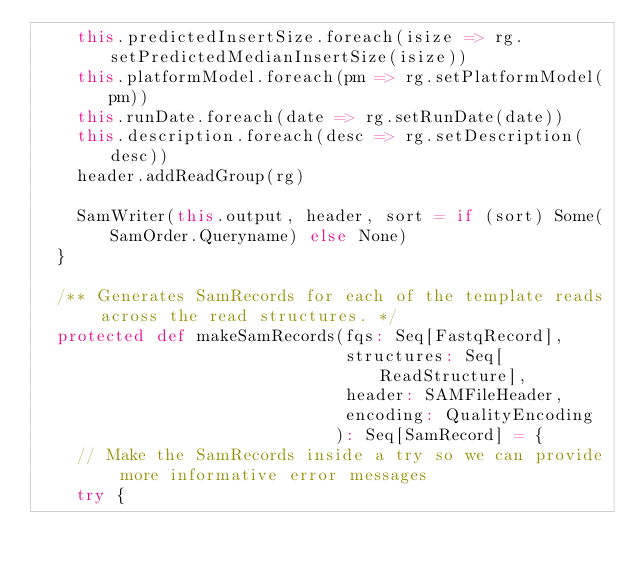<code> <loc_0><loc_0><loc_500><loc_500><_Scala_>    this.predictedInsertSize.foreach(isize => rg.setPredictedMedianInsertSize(isize))
    this.platformModel.foreach(pm => rg.setPlatformModel(pm))
    this.runDate.foreach(date => rg.setRunDate(date))
    this.description.foreach(desc => rg.setDescription(desc))
    header.addReadGroup(rg)

    SamWriter(this.output, header, sort = if (sort) Some(SamOrder.Queryname) else None)
  }

  /** Generates SamRecords for each of the template reads across the read structures. */
  protected def makeSamRecords(fqs: Seq[FastqRecord],
                               structures: Seq[ReadStructure],
                               header: SAMFileHeader,
                               encoding: QualityEncoding
                              ): Seq[SamRecord] = {
    // Make the SamRecords inside a try so we can provide more informative error messages
    try {</code> 